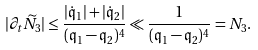Convert formula to latex. <formula><loc_0><loc_0><loc_500><loc_500>| \partial _ { t } \widetilde { N } _ { 3 } | \leq \frac { | \dot { \mathfrak { q } } _ { 1 } | + | \dot { \mathfrak { q } } _ { 2 } | } { ( \mathfrak { q } _ { 1 } - \mathfrak { q } _ { 2 } ) ^ { 4 } } \ll \frac { 1 } { ( \mathfrak { q } _ { 1 } - \mathfrak { q } _ { 2 } ) ^ { 4 } } = N _ { 3 } .</formula> 